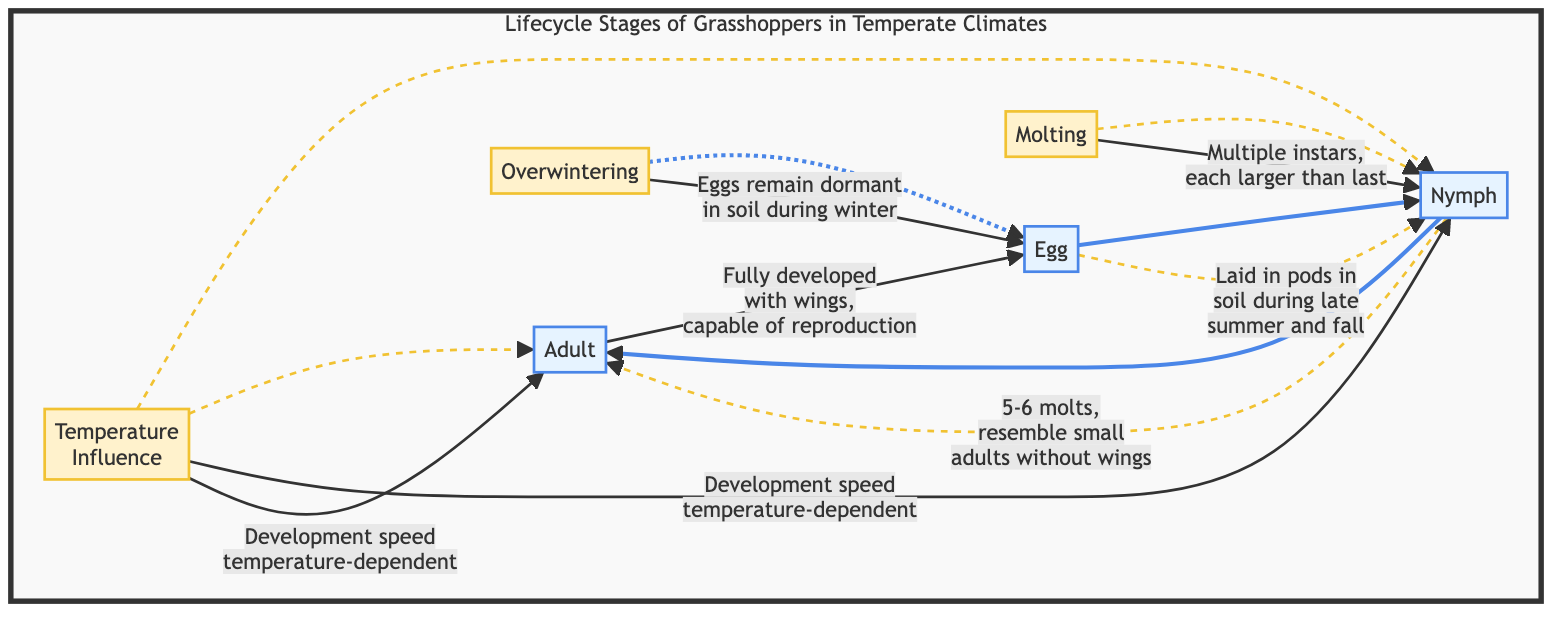What is the first stage in the lifecycle? The diagram indicates that the first stage in the lifecycle of grasshoppers is the "Egg". This is the starting point of the flowchart, and the arrows demonstrate the progression from this stage to the next.
Answer: Egg How many molts do nymphs go through? Referring to the flowchart, the description associated with the Nymph stage states that they go through "5-6 molts". This tells us the number of times nymphs molt before becoming adults.
Answer: 5-6 What type of class is used for the factors in the diagram? The diagram uses a specific class called "factorClass" for the factors, which includes Overwintering, Molting, and Temperature Influence. These classes define how these elements visually appear in the flowchart.
Answer: factorClass What relationship does "Temperature Influence" have? The "Temperature Influence" has a dashed line relationship indicated by the dotted arrows to both the Nymph and Adult stages. This shows that it affects both stages, demonstrating a connection based on temperature dependency for development.
Answer: Nymph and Adult What is described about egg dormancy? The flowchart indicates that the eggs "remain dormant in the soil during winter," which indicates their ability to survive harsh winter conditions without active development. This description provides important ecological insights into their lifecycle.
Answer: dormant in the soil during winter Explain the function of molting in nymphs. The molting process in nymphs, as depicted in the flowchart, occurs multiple times as they grow through "multiple instars," indicating that each molt results in a larger nymph. The relationship shows that the way they develop involves a series of growth stages characterized by their increasing size.
Answer: multiple instars, each larger than last Which lifecycle stage is capable of reproduction? According to the flowchart, the "Adult" stage is fully developed with wings and is capable of reproduction. This is highlighted as part of the transition from the Nymph stage to ensuring the continuation of the lifecycle.
Answer: Adult What seasonal influence does the lifecycle have? The cycle shows a significant seasonal influence, particularly for eggs in winter as they overwinter and remain dormant. This indicates how temperature and seasonal changes dictate the lifecycle stages and their activity levels.
Answer: seasonal influence in winter What connects the Nymph and Adult stages? The diagram shows a direct progression indicator (a solid arrow) between the Nymph and Adult stages, indicating that nymphs transition into adults after completing their molts. This direct flow suggests a linear development from one stage to the next.
Answer: direct progression 